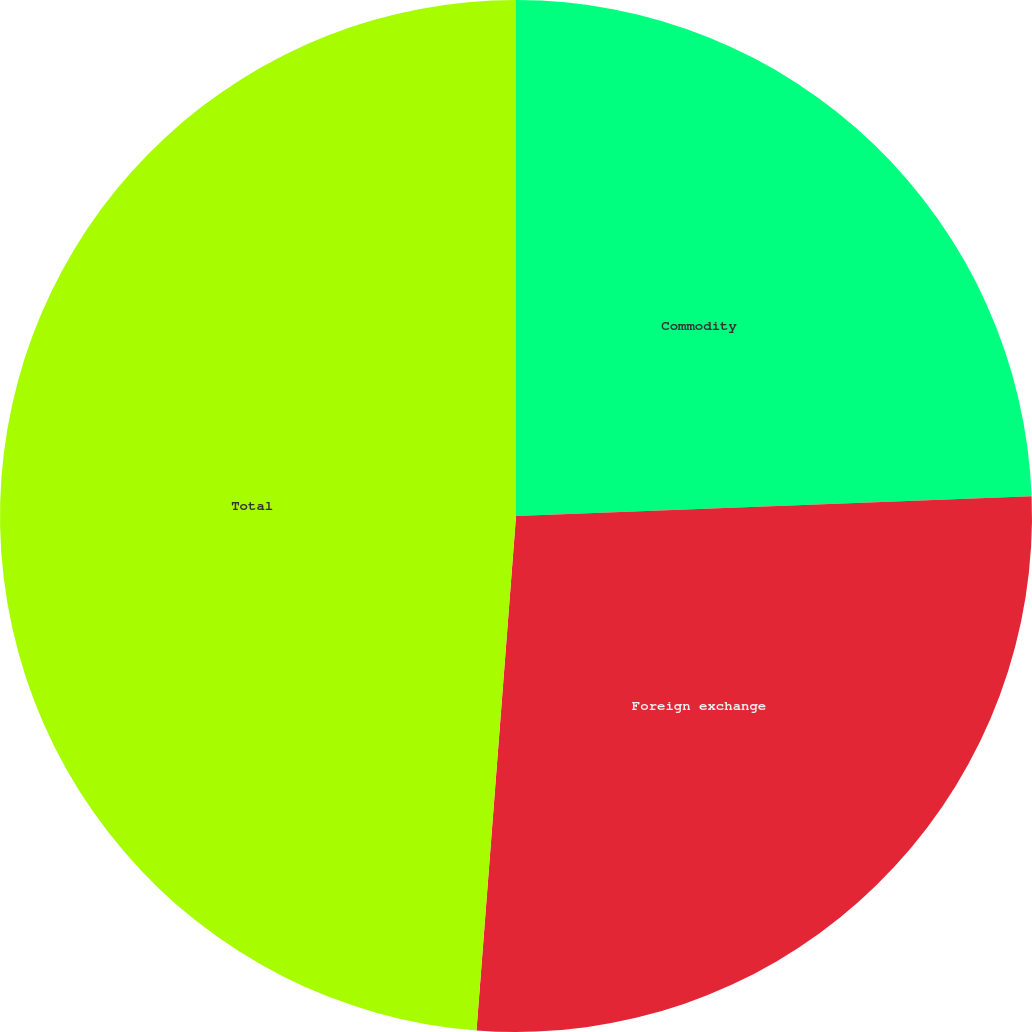Convert chart to OTSL. <chart><loc_0><loc_0><loc_500><loc_500><pie_chart><fcel>Commodity<fcel>Foreign exchange<fcel>Total<nl><fcel>24.39%<fcel>26.83%<fcel>48.78%<nl></chart> 